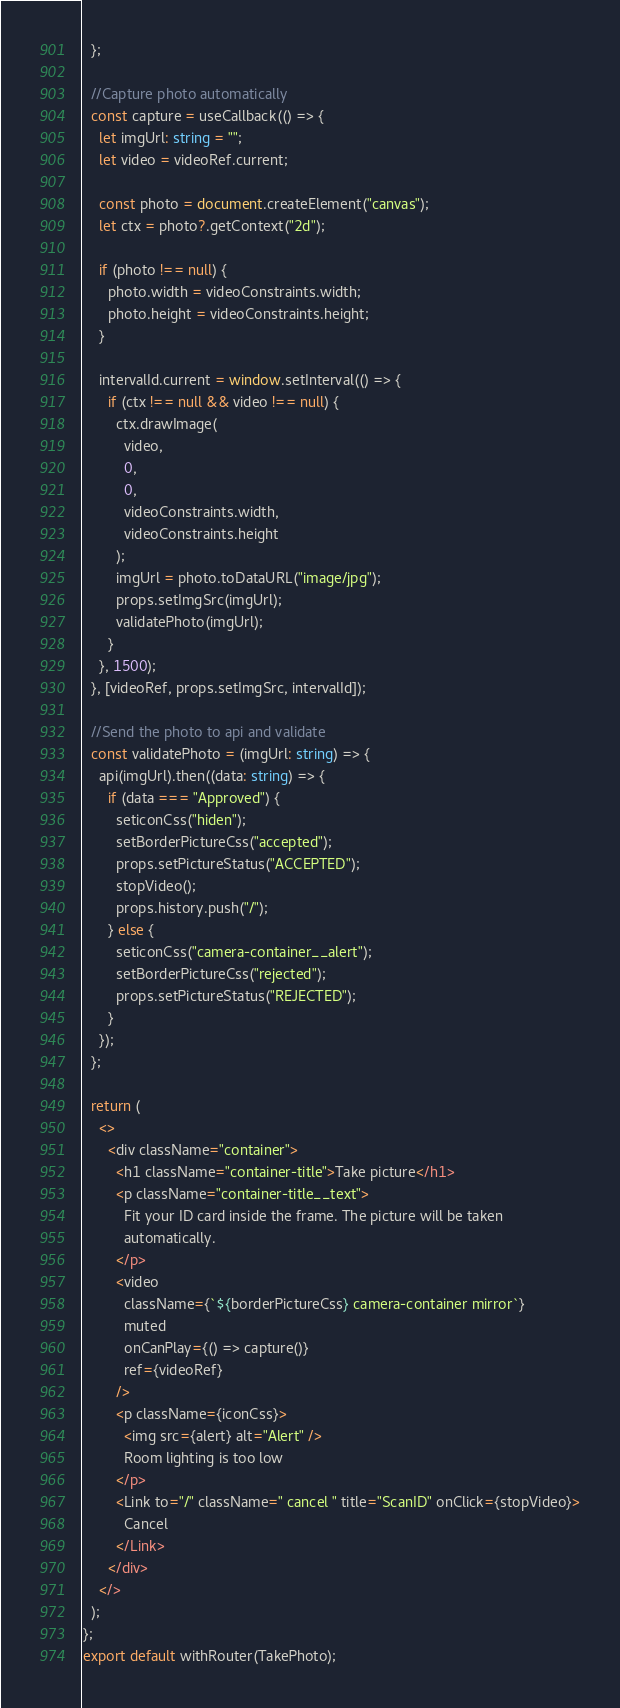Convert code to text. <code><loc_0><loc_0><loc_500><loc_500><_TypeScript_>  };

  //Capture photo automatically
  const capture = useCallback(() => {
    let imgUrl: string = "";
    let video = videoRef.current;

    const photo = document.createElement("canvas");
    let ctx = photo?.getContext("2d");

    if (photo !== null) {
      photo.width = videoConstraints.width;
      photo.height = videoConstraints.height;
    }

    intervalId.current = window.setInterval(() => {
      if (ctx !== null && video !== null) {
        ctx.drawImage(
          video,
          0,
          0,
          videoConstraints.width,
          videoConstraints.height
        );
        imgUrl = photo.toDataURL("image/jpg");
        props.setImgSrc(imgUrl);
        validatePhoto(imgUrl);
      }
    }, 1500);
  }, [videoRef, props.setImgSrc, intervalId]);

  //Send the photo to api and validate
  const validatePhoto = (imgUrl: string) => {
    api(imgUrl).then((data: string) => {
      if (data === "Approved") {
        seticonCss("hiden");
        setBorderPictureCss("accepted");
        props.setPictureStatus("ACCEPTED");
        stopVideo();
        props.history.push("/");
      } else {
        seticonCss("camera-container__alert");
        setBorderPictureCss("rejected");
        props.setPictureStatus("REJECTED");
      }
    });
  };

  return (
    <>
      <div className="container">
        <h1 className="container-title">Take picture</h1>
        <p className="container-title__text">
          Fit your ID card inside the frame. The picture will be taken
          automatically.
        </p>
        <video
          className={`${borderPictureCss} camera-container mirror`}
          muted
          onCanPlay={() => capture()}
          ref={videoRef}
        />
        <p className={iconCss}>
          <img src={alert} alt="Alert" />
          Room lighting is too low
        </p>
        <Link to="/" className=" cancel " title="ScanID" onClick={stopVideo}>
          Cancel
        </Link>
      </div>
    </>
  );
};
export default withRouter(TakePhoto);
</code> 